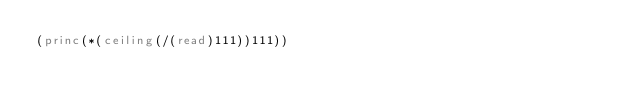<code> <loc_0><loc_0><loc_500><loc_500><_Lisp_>(princ(*(ceiling(/(read)111))111))</code> 